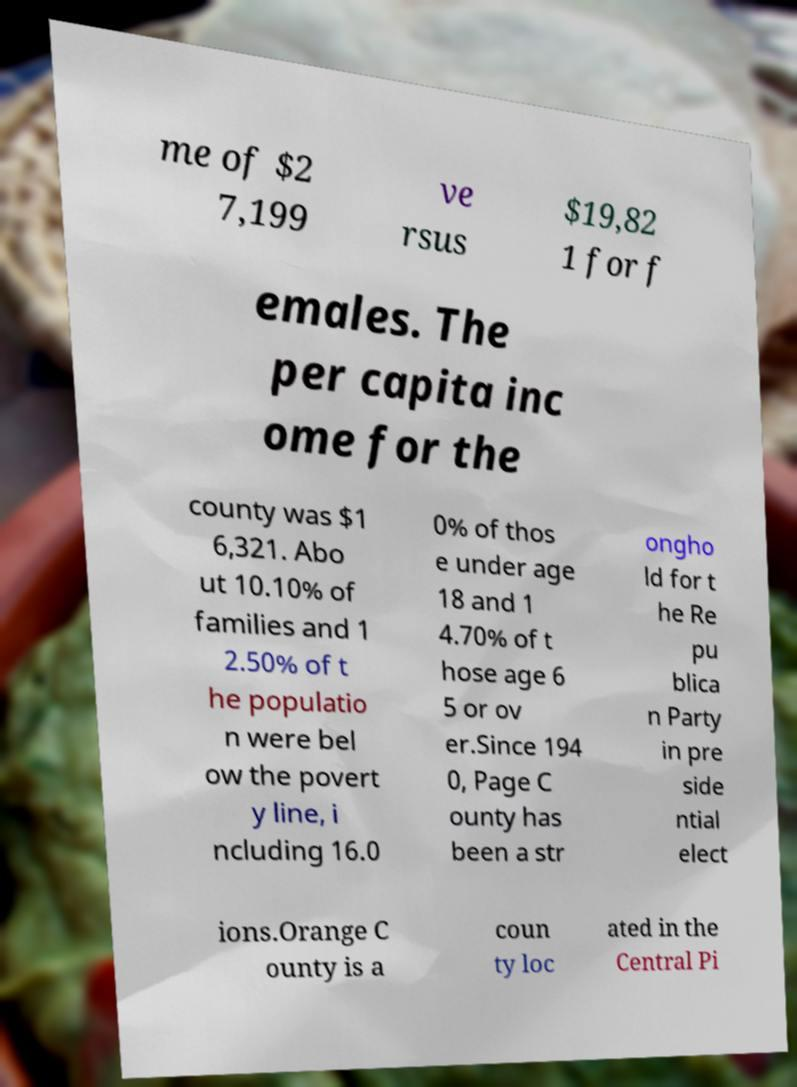Could you assist in decoding the text presented in this image and type it out clearly? me of $2 7,199 ve rsus $19,82 1 for f emales. The per capita inc ome for the county was $1 6,321. Abo ut 10.10% of families and 1 2.50% of t he populatio n were bel ow the povert y line, i ncluding 16.0 0% of thos e under age 18 and 1 4.70% of t hose age 6 5 or ov er.Since 194 0, Page C ounty has been a str ongho ld for t he Re pu blica n Party in pre side ntial elect ions.Orange C ounty is a coun ty loc ated in the Central Pi 